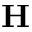Convert formula to latex. <formula><loc_0><loc_0><loc_500><loc_500>H</formula> 